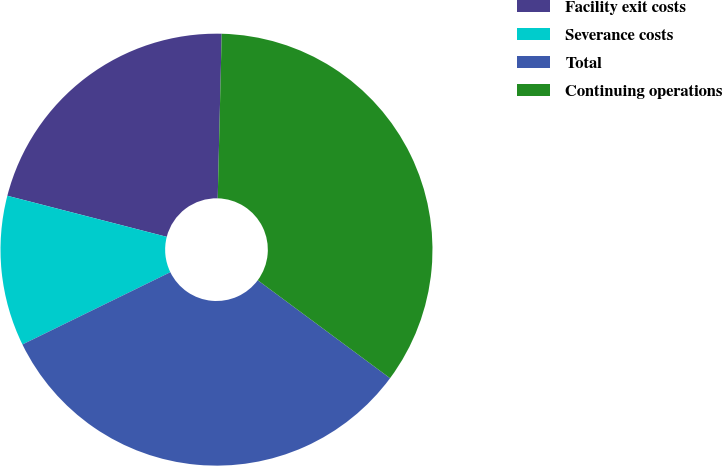<chart> <loc_0><loc_0><loc_500><loc_500><pie_chart><fcel>Facility exit costs<fcel>Severance costs<fcel>Total<fcel>Continuing operations<nl><fcel>21.37%<fcel>11.25%<fcel>32.62%<fcel>34.76%<nl></chart> 